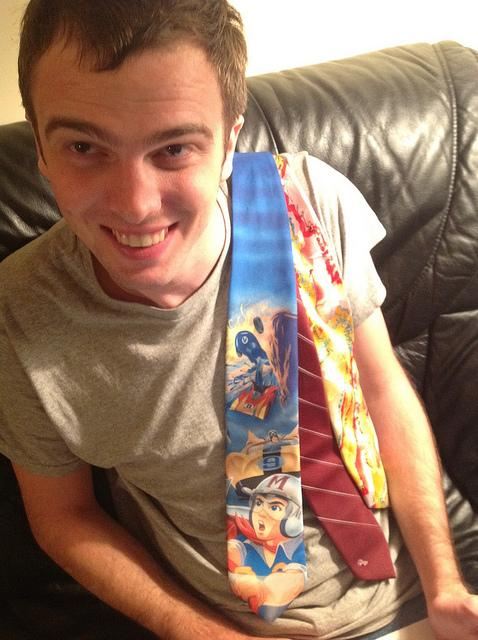What clothing item does the man have most of?

Choices:
A) ties
B) jeans
C) shirts
D) gloves ties 